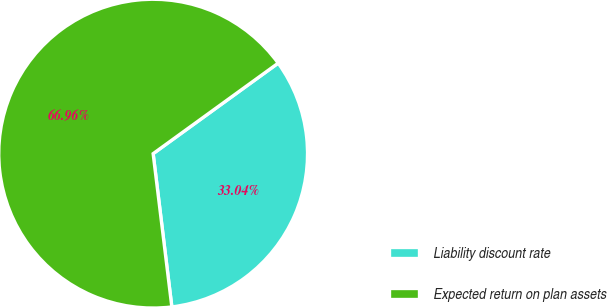Convert chart to OTSL. <chart><loc_0><loc_0><loc_500><loc_500><pie_chart><fcel>Liability discount rate<fcel>Expected return on plan assets<nl><fcel>33.04%<fcel>66.96%<nl></chart> 